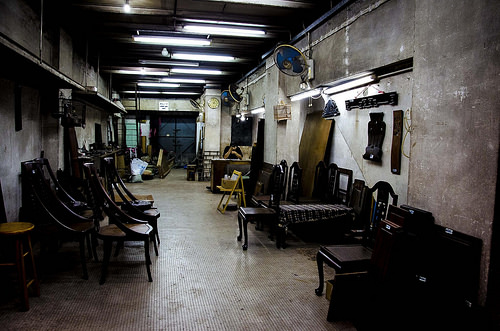<image>
Is there a tube light on the ceiling? Yes. Looking at the image, I can see the tube light is positioned on top of the ceiling, with the ceiling providing support. 